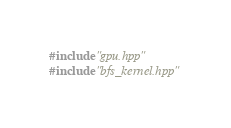Convert code to text. <code><loc_0><loc_0><loc_500><loc_500><_Cuda_>
#include "gpu.hpp"
#include "bfs_kernel.hpp"









</code> 